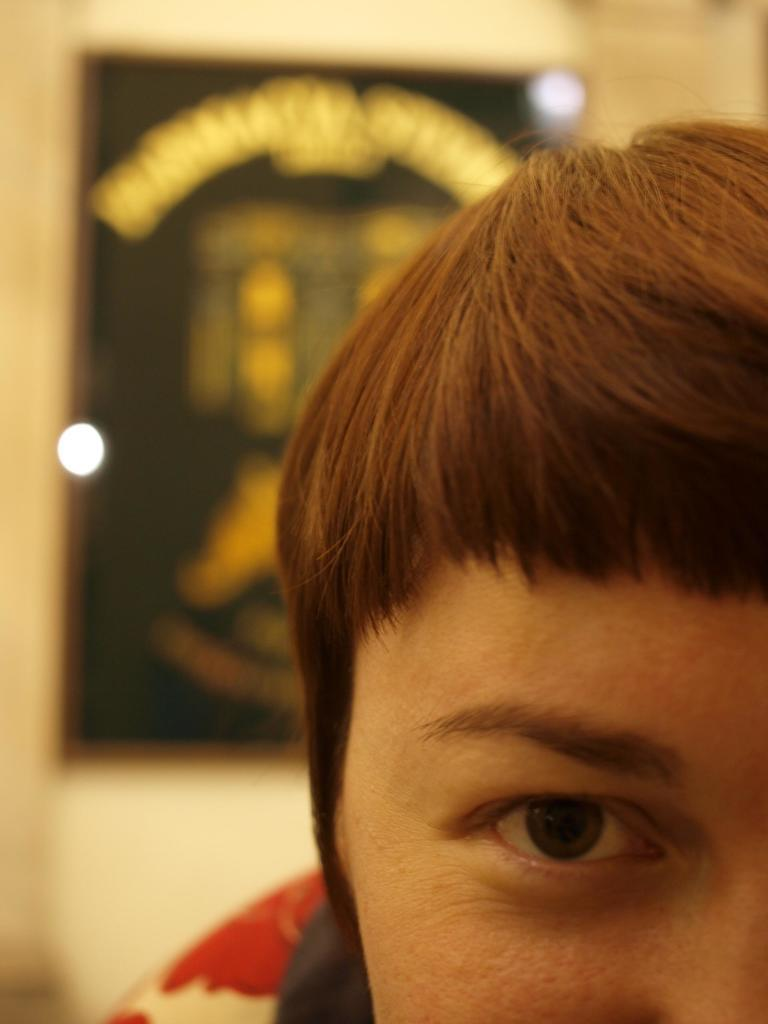What is the color of the wall in the image? The wall in the image is yellow. What object can be seen on the wall? There is a photo frame on the wall in the image. Who or what is in the front of the image? A person is standing in the front of the image. Where is the crook hiding in the image? There is no crook present in the image. How many trees can be seen in the image? There are no trees visible in the image. 